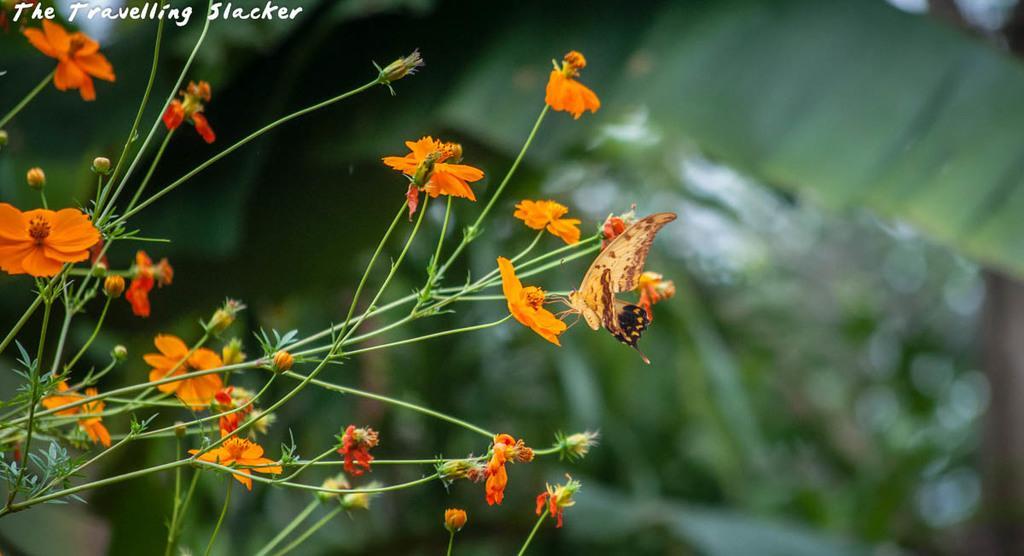How would you summarize this image in a sentence or two? On the left there is a plant with flowers and on a flower there is a butterfly. In the background the image is blur but we can see green leaves. 